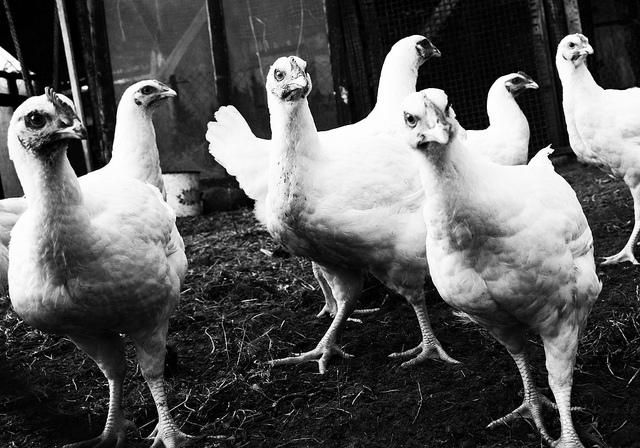What type of animal is in the image?

Choices:
A) chickens
B) ducks
C) cows
D) dogs chickens 